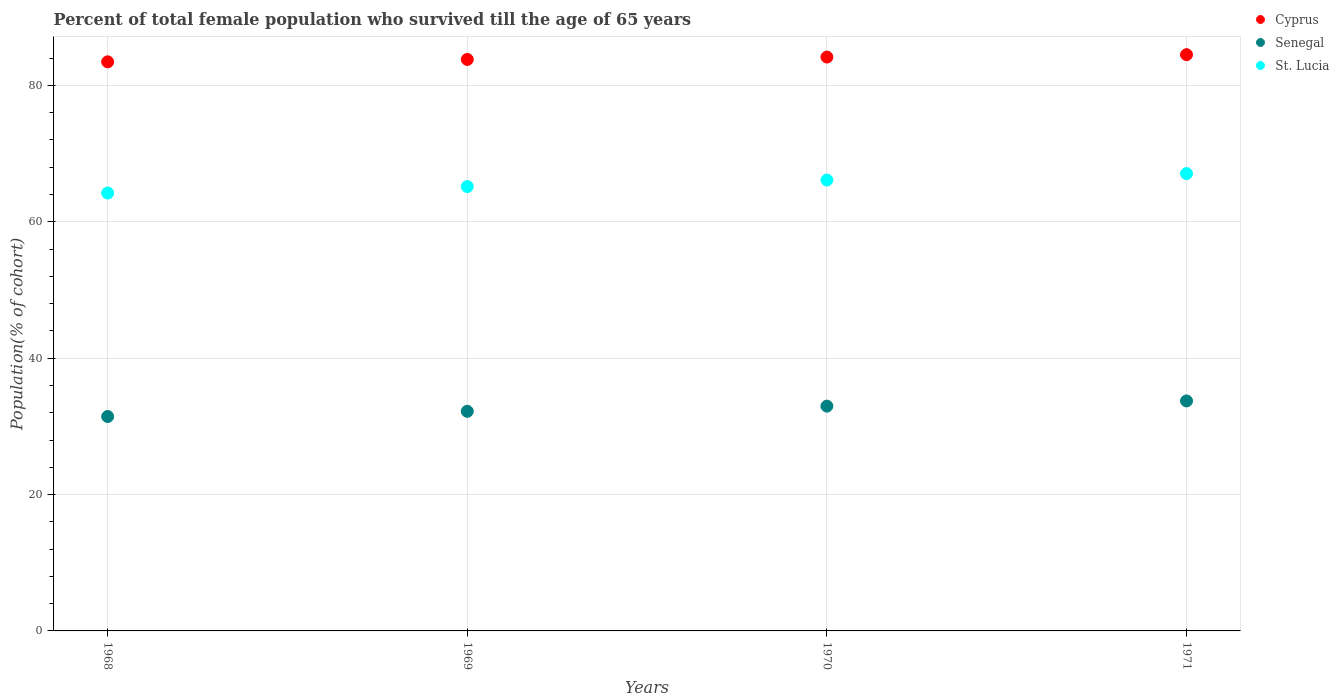Is the number of dotlines equal to the number of legend labels?
Make the answer very short. Yes. What is the percentage of total female population who survived till the age of 65 years in Cyprus in 1969?
Keep it short and to the point. 83.81. Across all years, what is the maximum percentage of total female population who survived till the age of 65 years in St. Lucia?
Make the answer very short. 67.08. Across all years, what is the minimum percentage of total female population who survived till the age of 65 years in Senegal?
Provide a succinct answer. 31.45. In which year was the percentage of total female population who survived till the age of 65 years in Senegal maximum?
Offer a very short reply. 1971. In which year was the percentage of total female population who survived till the age of 65 years in Cyprus minimum?
Offer a very short reply. 1968. What is the total percentage of total female population who survived till the age of 65 years in Cyprus in the graph?
Provide a short and direct response. 335.96. What is the difference between the percentage of total female population who survived till the age of 65 years in Cyprus in 1968 and that in 1970?
Provide a succinct answer. -0.7. What is the difference between the percentage of total female population who survived till the age of 65 years in St. Lucia in 1971 and the percentage of total female population who survived till the age of 65 years in Cyprus in 1968?
Ensure brevity in your answer.  -16.39. What is the average percentage of total female population who survived till the age of 65 years in Senegal per year?
Your answer should be compact. 32.59. In the year 1968, what is the difference between the percentage of total female population who survived till the age of 65 years in St. Lucia and percentage of total female population who survived till the age of 65 years in Senegal?
Ensure brevity in your answer.  32.78. What is the ratio of the percentage of total female population who survived till the age of 65 years in Senegal in 1968 to that in 1970?
Provide a succinct answer. 0.95. What is the difference between the highest and the second highest percentage of total female population who survived till the age of 65 years in Cyprus?
Offer a very short reply. 0.35. What is the difference between the highest and the lowest percentage of total female population who survived till the age of 65 years in Cyprus?
Provide a short and direct response. 1.05. Is the percentage of total female population who survived till the age of 65 years in Senegal strictly less than the percentage of total female population who survived till the age of 65 years in St. Lucia over the years?
Provide a short and direct response. Yes. Does the graph contain any zero values?
Your answer should be compact. No. How are the legend labels stacked?
Offer a very short reply. Vertical. What is the title of the graph?
Keep it short and to the point. Percent of total female population who survived till the age of 65 years. What is the label or title of the X-axis?
Provide a succinct answer. Years. What is the label or title of the Y-axis?
Offer a terse response. Population(% of cohort). What is the Population(% of cohort) in Cyprus in 1968?
Your answer should be compact. 83.46. What is the Population(% of cohort) in Senegal in 1968?
Give a very brief answer. 31.45. What is the Population(% of cohort) in St. Lucia in 1968?
Make the answer very short. 64.22. What is the Population(% of cohort) of Cyprus in 1969?
Offer a terse response. 83.81. What is the Population(% of cohort) in Senegal in 1969?
Provide a short and direct response. 32.21. What is the Population(% of cohort) of St. Lucia in 1969?
Give a very brief answer. 65.17. What is the Population(% of cohort) in Cyprus in 1970?
Your answer should be very brief. 84.16. What is the Population(% of cohort) in Senegal in 1970?
Keep it short and to the point. 32.97. What is the Population(% of cohort) in St. Lucia in 1970?
Your answer should be compact. 66.13. What is the Population(% of cohort) of Cyprus in 1971?
Your answer should be very brief. 84.51. What is the Population(% of cohort) of Senegal in 1971?
Offer a very short reply. 33.73. What is the Population(% of cohort) in St. Lucia in 1971?
Offer a very short reply. 67.08. Across all years, what is the maximum Population(% of cohort) in Cyprus?
Your answer should be very brief. 84.51. Across all years, what is the maximum Population(% of cohort) of Senegal?
Your response must be concise. 33.73. Across all years, what is the maximum Population(% of cohort) of St. Lucia?
Offer a very short reply. 67.08. Across all years, what is the minimum Population(% of cohort) of Cyprus?
Provide a short and direct response. 83.46. Across all years, what is the minimum Population(% of cohort) in Senegal?
Provide a short and direct response. 31.45. Across all years, what is the minimum Population(% of cohort) in St. Lucia?
Offer a terse response. 64.22. What is the total Population(% of cohort) of Cyprus in the graph?
Your answer should be very brief. 335.96. What is the total Population(% of cohort) in Senegal in the graph?
Your answer should be compact. 130.35. What is the total Population(% of cohort) of St. Lucia in the graph?
Make the answer very short. 262.6. What is the difference between the Population(% of cohort) of Cyprus in 1968 and that in 1969?
Keep it short and to the point. -0.35. What is the difference between the Population(% of cohort) in Senegal in 1968 and that in 1969?
Keep it short and to the point. -0.76. What is the difference between the Population(% of cohort) in St. Lucia in 1968 and that in 1969?
Make the answer very short. -0.95. What is the difference between the Population(% of cohort) of Cyprus in 1968 and that in 1970?
Your response must be concise. -0.7. What is the difference between the Population(% of cohort) in Senegal in 1968 and that in 1970?
Ensure brevity in your answer.  -1.52. What is the difference between the Population(% of cohort) in St. Lucia in 1968 and that in 1970?
Make the answer very short. -1.9. What is the difference between the Population(% of cohort) of Cyprus in 1968 and that in 1971?
Provide a short and direct response. -1.05. What is the difference between the Population(% of cohort) in Senegal in 1968 and that in 1971?
Provide a short and direct response. -2.28. What is the difference between the Population(% of cohort) of St. Lucia in 1968 and that in 1971?
Make the answer very short. -2.86. What is the difference between the Population(% of cohort) in Cyprus in 1969 and that in 1970?
Provide a short and direct response. -0.35. What is the difference between the Population(% of cohort) of Senegal in 1969 and that in 1970?
Offer a terse response. -0.76. What is the difference between the Population(% of cohort) in St. Lucia in 1969 and that in 1970?
Provide a succinct answer. -0.95. What is the difference between the Population(% of cohort) in Cyprus in 1969 and that in 1971?
Make the answer very short. -0.7. What is the difference between the Population(% of cohort) in Senegal in 1969 and that in 1971?
Keep it short and to the point. -1.52. What is the difference between the Population(% of cohort) of St. Lucia in 1969 and that in 1971?
Give a very brief answer. -1.9. What is the difference between the Population(% of cohort) in Cyprus in 1970 and that in 1971?
Offer a terse response. -0.35. What is the difference between the Population(% of cohort) in Senegal in 1970 and that in 1971?
Offer a terse response. -0.76. What is the difference between the Population(% of cohort) in St. Lucia in 1970 and that in 1971?
Offer a terse response. -0.95. What is the difference between the Population(% of cohort) in Cyprus in 1968 and the Population(% of cohort) in Senegal in 1969?
Offer a terse response. 51.26. What is the difference between the Population(% of cohort) of Cyprus in 1968 and the Population(% of cohort) of St. Lucia in 1969?
Provide a succinct answer. 18.29. What is the difference between the Population(% of cohort) of Senegal in 1968 and the Population(% of cohort) of St. Lucia in 1969?
Provide a succinct answer. -33.73. What is the difference between the Population(% of cohort) of Cyprus in 1968 and the Population(% of cohort) of Senegal in 1970?
Offer a terse response. 50.5. What is the difference between the Population(% of cohort) of Cyprus in 1968 and the Population(% of cohort) of St. Lucia in 1970?
Ensure brevity in your answer.  17.34. What is the difference between the Population(% of cohort) in Senegal in 1968 and the Population(% of cohort) in St. Lucia in 1970?
Your response must be concise. -34.68. What is the difference between the Population(% of cohort) of Cyprus in 1968 and the Population(% of cohort) of Senegal in 1971?
Make the answer very short. 49.73. What is the difference between the Population(% of cohort) of Cyprus in 1968 and the Population(% of cohort) of St. Lucia in 1971?
Keep it short and to the point. 16.39. What is the difference between the Population(% of cohort) in Senegal in 1968 and the Population(% of cohort) in St. Lucia in 1971?
Offer a terse response. -35.63. What is the difference between the Population(% of cohort) in Cyprus in 1969 and the Population(% of cohort) in Senegal in 1970?
Your answer should be compact. 50.85. What is the difference between the Population(% of cohort) in Cyprus in 1969 and the Population(% of cohort) in St. Lucia in 1970?
Offer a very short reply. 17.69. What is the difference between the Population(% of cohort) in Senegal in 1969 and the Population(% of cohort) in St. Lucia in 1970?
Offer a very short reply. -33.92. What is the difference between the Population(% of cohort) of Cyprus in 1969 and the Population(% of cohort) of Senegal in 1971?
Keep it short and to the point. 50.08. What is the difference between the Population(% of cohort) of Cyprus in 1969 and the Population(% of cohort) of St. Lucia in 1971?
Provide a short and direct response. 16.74. What is the difference between the Population(% of cohort) in Senegal in 1969 and the Population(% of cohort) in St. Lucia in 1971?
Offer a very short reply. -34.87. What is the difference between the Population(% of cohort) in Cyprus in 1970 and the Population(% of cohort) in Senegal in 1971?
Offer a very short reply. 50.43. What is the difference between the Population(% of cohort) of Cyprus in 1970 and the Population(% of cohort) of St. Lucia in 1971?
Offer a very short reply. 17.09. What is the difference between the Population(% of cohort) in Senegal in 1970 and the Population(% of cohort) in St. Lucia in 1971?
Your answer should be very brief. -34.11. What is the average Population(% of cohort) in Cyprus per year?
Ensure brevity in your answer.  83.99. What is the average Population(% of cohort) of Senegal per year?
Ensure brevity in your answer.  32.59. What is the average Population(% of cohort) of St. Lucia per year?
Give a very brief answer. 65.65. In the year 1968, what is the difference between the Population(% of cohort) in Cyprus and Population(% of cohort) in Senegal?
Ensure brevity in your answer.  52.02. In the year 1968, what is the difference between the Population(% of cohort) in Cyprus and Population(% of cohort) in St. Lucia?
Make the answer very short. 19.24. In the year 1968, what is the difference between the Population(% of cohort) of Senegal and Population(% of cohort) of St. Lucia?
Ensure brevity in your answer.  -32.78. In the year 1969, what is the difference between the Population(% of cohort) in Cyprus and Population(% of cohort) in Senegal?
Your answer should be very brief. 51.61. In the year 1969, what is the difference between the Population(% of cohort) in Cyprus and Population(% of cohort) in St. Lucia?
Give a very brief answer. 18.64. In the year 1969, what is the difference between the Population(% of cohort) of Senegal and Population(% of cohort) of St. Lucia?
Ensure brevity in your answer.  -32.97. In the year 1970, what is the difference between the Population(% of cohort) in Cyprus and Population(% of cohort) in Senegal?
Keep it short and to the point. 51.2. In the year 1970, what is the difference between the Population(% of cohort) of Cyprus and Population(% of cohort) of St. Lucia?
Keep it short and to the point. 18.04. In the year 1970, what is the difference between the Population(% of cohort) of Senegal and Population(% of cohort) of St. Lucia?
Ensure brevity in your answer.  -33.16. In the year 1971, what is the difference between the Population(% of cohort) in Cyprus and Population(% of cohort) in Senegal?
Ensure brevity in your answer.  50.78. In the year 1971, what is the difference between the Population(% of cohort) in Cyprus and Population(% of cohort) in St. Lucia?
Your response must be concise. 17.44. In the year 1971, what is the difference between the Population(% of cohort) of Senegal and Population(% of cohort) of St. Lucia?
Provide a succinct answer. -33.35. What is the ratio of the Population(% of cohort) in Cyprus in 1968 to that in 1969?
Ensure brevity in your answer.  1. What is the ratio of the Population(% of cohort) of Senegal in 1968 to that in 1969?
Offer a very short reply. 0.98. What is the ratio of the Population(% of cohort) of St. Lucia in 1968 to that in 1969?
Provide a short and direct response. 0.99. What is the ratio of the Population(% of cohort) in Cyprus in 1968 to that in 1970?
Your answer should be compact. 0.99. What is the ratio of the Population(% of cohort) of Senegal in 1968 to that in 1970?
Provide a short and direct response. 0.95. What is the ratio of the Population(% of cohort) of St. Lucia in 1968 to that in 1970?
Your response must be concise. 0.97. What is the ratio of the Population(% of cohort) in Cyprus in 1968 to that in 1971?
Make the answer very short. 0.99. What is the ratio of the Population(% of cohort) of Senegal in 1968 to that in 1971?
Ensure brevity in your answer.  0.93. What is the ratio of the Population(% of cohort) in St. Lucia in 1968 to that in 1971?
Keep it short and to the point. 0.96. What is the ratio of the Population(% of cohort) of Cyprus in 1969 to that in 1970?
Your answer should be very brief. 1. What is the ratio of the Population(% of cohort) in Senegal in 1969 to that in 1970?
Your response must be concise. 0.98. What is the ratio of the Population(% of cohort) in St. Lucia in 1969 to that in 1970?
Give a very brief answer. 0.99. What is the ratio of the Population(% of cohort) of Cyprus in 1969 to that in 1971?
Your answer should be very brief. 0.99. What is the ratio of the Population(% of cohort) in Senegal in 1969 to that in 1971?
Your answer should be compact. 0.95. What is the ratio of the Population(% of cohort) of St. Lucia in 1969 to that in 1971?
Give a very brief answer. 0.97. What is the ratio of the Population(% of cohort) of Cyprus in 1970 to that in 1971?
Your response must be concise. 1. What is the ratio of the Population(% of cohort) in Senegal in 1970 to that in 1971?
Your answer should be compact. 0.98. What is the ratio of the Population(% of cohort) of St. Lucia in 1970 to that in 1971?
Keep it short and to the point. 0.99. What is the difference between the highest and the second highest Population(% of cohort) in Cyprus?
Give a very brief answer. 0.35. What is the difference between the highest and the second highest Population(% of cohort) in Senegal?
Offer a terse response. 0.76. What is the difference between the highest and the lowest Population(% of cohort) in Cyprus?
Offer a very short reply. 1.05. What is the difference between the highest and the lowest Population(% of cohort) in Senegal?
Give a very brief answer. 2.28. What is the difference between the highest and the lowest Population(% of cohort) in St. Lucia?
Your answer should be very brief. 2.86. 